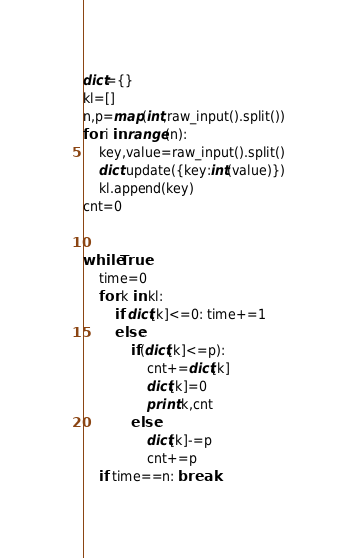<code> <loc_0><loc_0><loc_500><loc_500><_Python_>dict={}
kl=[]
n,p=map(int,raw_input().split())
for i in range(n):
	key,value=raw_input().split()
	dict.update({key:int(value)})
	kl.append(key)
cnt=0


while True:
	time=0
	for k in kl:
		if dict[k]<=0: time+=1
		else:
			if(dict[k]<=p):
				cnt+=dict[k]
				dict[k]=0
				print k,cnt	
			else:
				dict[k]-=p
				cnt+=p
	if time==n: break</code> 